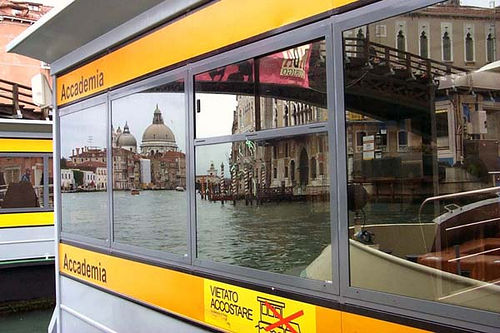Please provide a short description for this region: [0.0, 0.17, 0.11, 0.8]. The selected region captures a detailed view of a boat and a bridge in the background, giving an impression of a busy waterway and infrastructure built over it. 